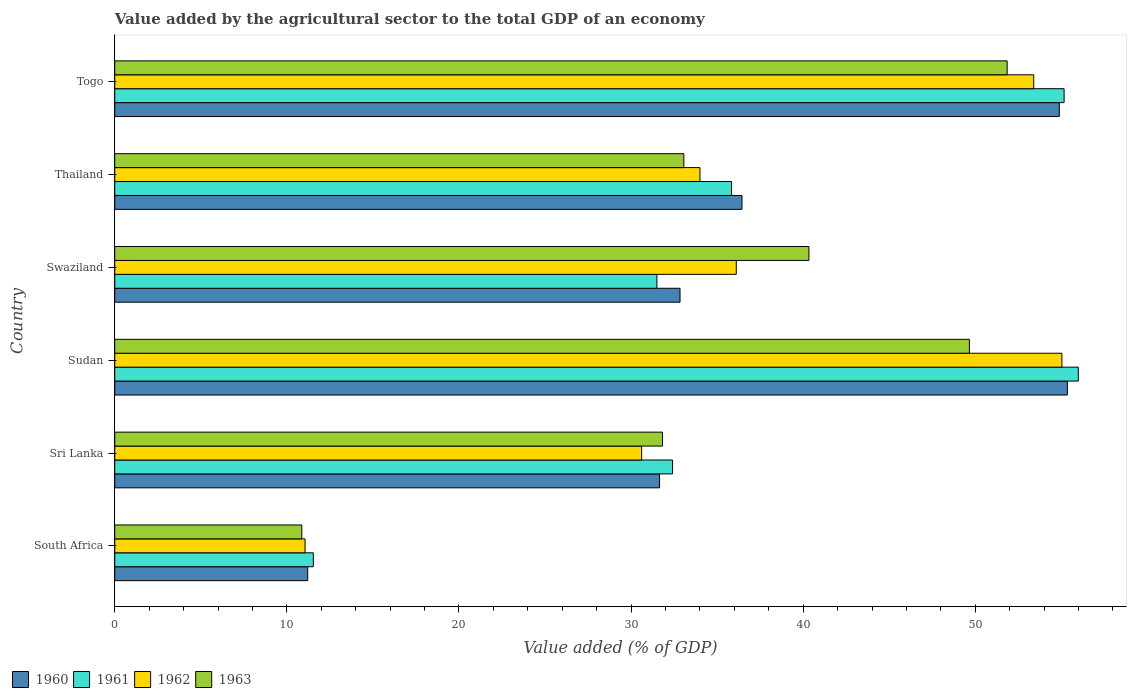How many different coloured bars are there?
Provide a succinct answer. 4. How many groups of bars are there?
Your answer should be compact. 6. What is the label of the 1st group of bars from the top?
Make the answer very short. Togo. In how many cases, is the number of bars for a given country not equal to the number of legend labels?
Offer a terse response. 0. What is the value added by the agricultural sector to the total GDP in 1961 in Togo?
Your answer should be compact. 55.16. Across all countries, what is the maximum value added by the agricultural sector to the total GDP in 1960?
Ensure brevity in your answer.  55.35. Across all countries, what is the minimum value added by the agricultural sector to the total GDP in 1960?
Give a very brief answer. 11.21. In which country was the value added by the agricultural sector to the total GDP in 1961 maximum?
Provide a short and direct response. Sudan. In which country was the value added by the agricultural sector to the total GDP in 1962 minimum?
Make the answer very short. South Africa. What is the total value added by the agricultural sector to the total GDP in 1961 in the graph?
Your response must be concise. 222.43. What is the difference between the value added by the agricultural sector to the total GDP in 1960 in South Africa and that in Sri Lanka?
Offer a very short reply. -20.45. What is the difference between the value added by the agricultural sector to the total GDP in 1963 in Sudan and the value added by the agricultural sector to the total GDP in 1962 in Thailand?
Give a very brief answer. 15.66. What is the average value added by the agricultural sector to the total GDP in 1961 per country?
Your answer should be very brief. 37.07. What is the difference between the value added by the agricultural sector to the total GDP in 1963 and value added by the agricultural sector to the total GDP in 1960 in Swaziland?
Provide a succinct answer. 7.49. What is the ratio of the value added by the agricultural sector to the total GDP in 1960 in Sri Lanka to that in Thailand?
Offer a terse response. 0.87. Is the difference between the value added by the agricultural sector to the total GDP in 1963 in South Africa and Sri Lanka greater than the difference between the value added by the agricultural sector to the total GDP in 1960 in South Africa and Sri Lanka?
Keep it short and to the point. No. What is the difference between the highest and the second highest value added by the agricultural sector to the total GDP in 1960?
Ensure brevity in your answer.  0.47. What is the difference between the highest and the lowest value added by the agricultural sector to the total GDP in 1961?
Give a very brief answer. 44.45. Is the sum of the value added by the agricultural sector to the total GDP in 1961 in South Africa and Sri Lanka greater than the maximum value added by the agricultural sector to the total GDP in 1963 across all countries?
Your answer should be very brief. No. Is it the case that in every country, the sum of the value added by the agricultural sector to the total GDP in 1962 and value added by the agricultural sector to the total GDP in 1960 is greater than the sum of value added by the agricultural sector to the total GDP in 1961 and value added by the agricultural sector to the total GDP in 1963?
Keep it short and to the point. No. What does the 3rd bar from the top in South Africa represents?
Give a very brief answer. 1961. Are all the bars in the graph horizontal?
Your response must be concise. Yes. How many countries are there in the graph?
Make the answer very short. 6. Are the values on the major ticks of X-axis written in scientific E-notation?
Offer a terse response. No. Does the graph contain any zero values?
Your answer should be compact. No. Does the graph contain grids?
Provide a succinct answer. No. Where does the legend appear in the graph?
Offer a very short reply. Bottom left. How are the legend labels stacked?
Your answer should be compact. Horizontal. What is the title of the graph?
Keep it short and to the point. Value added by the agricultural sector to the total GDP of an economy. What is the label or title of the X-axis?
Make the answer very short. Value added (% of GDP). What is the label or title of the Y-axis?
Make the answer very short. Country. What is the Value added (% of GDP) of 1960 in South Africa?
Keep it short and to the point. 11.21. What is the Value added (% of GDP) in 1961 in South Africa?
Make the answer very short. 11.54. What is the Value added (% of GDP) of 1962 in South Africa?
Keep it short and to the point. 11.06. What is the Value added (% of GDP) of 1963 in South Africa?
Your response must be concise. 10.87. What is the Value added (% of GDP) in 1960 in Sri Lanka?
Offer a very short reply. 31.66. What is the Value added (% of GDP) in 1961 in Sri Lanka?
Keep it short and to the point. 32.41. What is the Value added (% of GDP) of 1962 in Sri Lanka?
Offer a terse response. 30.61. What is the Value added (% of GDP) in 1963 in Sri Lanka?
Your answer should be compact. 31.83. What is the Value added (% of GDP) in 1960 in Sudan?
Provide a short and direct response. 55.35. What is the Value added (% of GDP) in 1961 in Sudan?
Give a very brief answer. 55.99. What is the Value added (% of GDP) in 1962 in Sudan?
Ensure brevity in your answer.  55.03. What is the Value added (% of GDP) of 1963 in Sudan?
Your answer should be very brief. 49.66. What is the Value added (% of GDP) in 1960 in Swaziland?
Offer a terse response. 32.84. What is the Value added (% of GDP) in 1961 in Swaziland?
Give a very brief answer. 31.5. What is the Value added (% of GDP) of 1962 in Swaziland?
Provide a succinct answer. 36.11. What is the Value added (% of GDP) of 1963 in Swaziland?
Provide a short and direct response. 40.33. What is the Value added (% of GDP) of 1960 in Thailand?
Ensure brevity in your answer.  36.44. What is the Value added (% of GDP) of 1961 in Thailand?
Ensure brevity in your answer.  35.84. What is the Value added (% of GDP) in 1962 in Thailand?
Provide a succinct answer. 34. What is the Value added (% of GDP) in 1963 in Thailand?
Provide a succinct answer. 33.07. What is the Value added (% of GDP) of 1960 in Togo?
Your answer should be very brief. 54.88. What is the Value added (% of GDP) of 1961 in Togo?
Give a very brief answer. 55.16. What is the Value added (% of GDP) in 1962 in Togo?
Ensure brevity in your answer.  53.4. What is the Value added (% of GDP) of 1963 in Togo?
Your answer should be very brief. 51.85. Across all countries, what is the maximum Value added (% of GDP) in 1960?
Your response must be concise. 55.35. Across all countries, what is the maximum Value added (% of GDP) in 1961?
Your answer should be compact. 55.99. Across all countries, what is the maximum Value added (% of GDP) in 1962?
Your answer should be compact. 55.03. Across all countries, what is the maximum Value added (% of GDP) in 1963?
Give a very brief answer. 51.85. Across all countries, what is the minimum Value added (% of GDP) in 1960?
Make the answer very short. 11.21. Across all countries, what is the minimum Value added (% of GDP) of 1961?
Provide a short and direct response. 11.54. Across all countries, what is the minimum Value added (% of GDP) in 1962?
Provide a succinct answer. 11.06. Across all countries, what is the minimum Value added (% of GDP) of 1963?
Offer a terse response. 10.87. What is the total Value added (% of GDP) of 1960 in the graph?
Your answer should be very brief. 222.39. What is the total Value added (% of GDP) in 1961 in the graph?
Ensure brevity in your answer.  222.44. What is the total Value added (% of GDP) in 1962 in the graph?
Your response must be concise. 220.21. What is the total Value added (% of GDP) in 1963 in the graph?
Provide a succinct answer. 217.6. What is the difference between the Value added (% of GDP) in 1960 in South Africa and that in Sri Lanka?
Provide a succinct answer. -20.45. What is the difference between the Value added (% of GDP) of 1961 in South Africa and that in Sri Lanka?
Your answer should be very brief. -20.87. What is the difference between the Value added (% of GDP) of 1962 in South Africa and that in Sri Lanka?
Offer a very short reply. -19.56. What is the difference between the Value added (% of GDP) of 1963 in South Africa and that in Sri Lanka?
Keep it short and to the point. -20.96. What is the difference between the Value added (% of GDP) in 1960 in South Africa and that in Sudan?
Keep it short and to the point. -44.14. What is the difference between the Value added (% of GDP) of 1961 in South Africa and that in Sudan?
Give a very brief answer. -44.45. What is the difference between the Value added (% of GDP) of 1962 in South Africa and that in Sudan?
Provide a short and direct response. -43.98. What is the difference between the Value added (% of GDP) of 1963 in South Africa and that in Sudan?
Ensure brevity in your answer.  -38.79. What is the difference between the Value added (% of GDP) of 1960 in South Africa and that in Swaziland?
Make the answer very short. -21.63. What is the difference between the Value added (% of GDP) of 1961 in South Africa and that in Swaziland?
Your answer should be compact. -19.96. What is the difference between the Value added (% of GDP) of 1962 in South Africa and that in Swaziland?
Your response must be concise. -25.06. What is the difference between the Value added (% of GDP) in 1963 in South Africa and that in Swaziland?
Give a very brief answer. -29.46. What is the difference between the Value added (% of GDP) in 1960 in South Africa and that in Thailand?
Provide a succinct answer. -25.23. What is the difference between the Value added (% of GDP) of 1961 in South Africa and that in Thailand?
Ensure brevity in your answer.  -24.3. What is the difference between the Value added (% of GDP) in 1962 in South Africa and that in Thailand?
Offer a terse response. -22.95. What is the difference between the Value added (% of GDP) in 1963 in South Africa and that in Thailand?
Your answer should be very brief. -22.2. What is the difference between the Value added (% of GDP) in 1960 in South Africa and that in Togo?
Make the answer very short. -43.67. What is the difference between the Value added (% of GDP) in 1961 in South Africa and that in Togo?
Your answer should be compact. -43.62. What is the difference between the Value added (% of GDP) of 1962 in South Africa and that in Togo?
Keep it short and to the point. -42.34. What is the difference between the Value added (% of GDP) of 1963 in South Africa and that in Togo?
Ensure brevity in your answer.  -40.98. What is the difference between the Value added (% of GDP) of 1960 in Sri Lanka and that in Sudan?
Keep it short and to the point. -23.7. What is the difference between the Value added (% of GDP) in 1961 in Sri Lanka and that in Sudan?
Keep it short and to the point. -23.58. What is the difference between the Value added (% of GDP) in 1962 in Sri Lanka and that in Sudan?
Give a very brief answer. -24.42. What is the difference between the Value added (% of GDP) in 1963 in Sri Lanka and that in Sudan?
Your answer should be very brief. -17.83. What is the difference between the Value added (% of GDP) in 1960 in Sri Lanka and that in Swaziland?
Make the answer very short. -1.19. What is the difference between the Value added (% of GDP) in 1961 in Sri Lanka and that in Swaziland?
Ensure brevity in your answer.  0.91. What is the difference between the Value added (% of GDP) of 1962 in Sri Lanka and that in Swaziland?
Offer a terse response. -5.5. What is the difference between the Value added (% of GDP) in 1963 in Sri Lanka and that in Swaziland?
Provide a succinct answer. -8.51. What is the difference between the Value added (% of GDP) of 1960 in Sri Lanka and that in Thailand?
Provide a short and direct response. -4.79. What is the difference between the Value added (% of GDP) of 1961 in Sri Lanka and that in Thailand?
Your answer should be very brief. -3.43. What is the difference between the Value added (% of GDP) of 1962 in Sri Lanka and that in Thailand?
Ensure brevity in your answer.  -3.39. What is the difference between the Value added (% of GDP) in 1963 in Sri Lanka and that in Thailand?
Give a very brief answer. -1.24. What is the difference between the Value added (% of GDP) of 1960 in Sri Lanka and that in Togo?
Make the answer very short. -23.23. What is the difference between the Value added (% of GDP) in 1961 in Sri Lanka and that in Togo?
Your response must be concise. -22.75. What is the difference between the Value added (% of GDP) of 1962 in Sri Lanka and that in Togo?
Offer a terse response. -22.78. What is the difference between the Value added (% of GDP) in 1963 in Sri Lanka and that in Togo?
Provide a succinct answer. -20.03. What is the difference between the Value added (% of GDP) in 1960 in Sudan and that in Swaziland?
Provide a short and direct response. 22.51. What is the difference between the Value added (% of GDP) in 1961 in Sudan and that in Swaziland?
Your answer should be compact. 24.49. What is the difference between the Value added (% of GDP) of 1962 in Sudan and that in Swaziland?
Offer a terse response. 18.92. What is the difference between the Value added (% of GDP) in 1963 in Sudan and that in Swaziland?
Give a very brief answer. 9.32. What is the difference between the Value added (% of GDP) in 1960 in Sudan and that in Thailand?
Offer a terse response. 18.91. What is the difference between the Value added (% of GDP) of 1961 in Sudan and that in Thailand?
Keep it short and to the point. 20.15. What is the difference between the Value added (% of GDP) in 1962 in Sudan and that in Thailand?
Provide a succinct answer. 21.03. What is the difference between the Value added (% of GDP) in 1963 in Sudan and that in Thailand?
Give a very brief answer. 16.59. What is the difference between the Value added (% of GDP) of 1960 in Sudan and that in Togo?
Your response must be concise. 0.47. What is the difference between the Value added (% of GDP) in 1961 in Sudan and that in Togo?
Provide a short and direct response. 0.83. What is the difference between the Value added (% of GDP) in 1962 in Sudan and that in Togo?
Provide a succinct answer. 1.64. What is the difference between the Value added (% of GDP) of 1963 in Sudan and that in Togo?
Offer a terse response. -2.19. What is the difference between the Value added (% of GDP) of 1960 in Swaziland and that in Thailand?
Provide a succinct answer. -3.6. What is the difference between the Value added (% of GDP) in 1961 in Swaziland and that in Thailand?
Your answer should be very brief. -4.34. What is the difference between the Value added (% of GDP) in 1962 in Swaziland and that in Thailand?
Offer a very short reply. 2.11. What is the difference between the Value added (% of GDP) of 1963 in Swaziland and that in Thailand?
Ensure brevity in your answer.  7.27. What is the difference between the Value added (% of GDP) of 1960 in Swaziland and that in Togo?
Ensure brevity in your answer.  -22.04. What is the difference between the Value added (% of GDP) in 1961 in Swaziland and that in Togo?
Your answer should be very brief. -23.66. What is the difference between the Value added (% of GDP) in 1962 in Swaziland and that in Togo?
Make the answer very short. -17.28. What is the difference between the Value added (% of GDP) of 1963 in Swaziland and that in Togo?
Provide a succinct answer. -11.52. What is the difference between the Value added (% of GDP) of 1960 in Thailand and that in Togo?
Keep it short and to the point. -18.44. What is the difference between the Value added (% of GDP) of 1961 in Thailand and that in Togo?
Give a very brief answer. -19.32. What is the difference between the Value added (% of GDP) of 1962 in Thailand and that in Togo?
Keep it short and to the point. -19.39. What is the difference between the Value added (% of GDP) in 1963 in Thailand and that in Togo?
Give a very brief answer. -18.79. What is the difference between the Value added (% of GDP) of 1960 in South Africa and the Value added (% of GDP) of 1961 in Sri Lanka?
Provide a succinct answer. -21.2. What is the difference between the Value added (% of GDP) in 1960 in South Africa and the Value added (% of GDP) in 1962 in Sri Lanka?
Your answer should be compact. -19.4. What is the difference between the Value added (% of GDP) in 1960 in South Africa and the Value added (% of GDP) in 1963 in Sri Lanka?
Keep it short and to the point. -20.62. What is the difference between the Value added (% of GDP) in 1961 in South Africa and the Value added (% of GDP) in 1962 in Sri Lanka?
Keep it short and to the point. -19.08. What is the difference between the Value added (% of GDP) in 1961 in South Africa and the Value added (% of GDP) in 1963 in Sri Lanka?
Your response must be concise. -20.29. What is the difference between the Value added (% of GDP) in 1962 in South Africa and the Value added (% of GDP) in 1963 in Sri Lanka?
Your answer should be very brief. -20.77. What is the difference between the Value added (% of GDP) of 1960 in South Africa and the Value added (% of GDP) of 1961 in Sudan?
Ensure brevity in your answer.  -44.78. What is the difference between the Value added (% of GDP) of 1960 in South Africa and the Value added (% of GDP) of 1962 in Sudan?
Give a very brief answer. -43.82. What is the difference between the Value added (% of GDP) of 1960 in South Africa and the Value added (% of GDP) of 1963 in Sudan?
Keep it short and to the point. -38.45. What is the difference between the Value added (% of GDP) of 1961 in South Africa and the Value added (% of GDP) of 1962 in Sudan?
Give a very brief answer. -43.5. What is the difference between the Value added (% of GDP) in 1961 in South Africa and the Value added (% of GDP) in 1963 in Sudan?
Ensure brevity in your answer.  -38.12. What is the difference between the Value added (% of GDP) in 1962 in South Africa and the Value added (% of GDP) in 1963 in Sudan?
Offer a terse response. -38.6. What is the difference between the Value added (% of GDP) in 1960 in South Africa and the Value added (% of GDP) in 1961 in Swaziland?
Keep it short and to the point. -20.29. What is the difference between the Value added (% of GDP) of 1960 in South Africa and the Value added (% of GDP) of 1962 in Swaziland?
Your answer should be very brief. -24.9. What is the difference between the Value added (% of GDP) of 1960 in South Africa and the Value added (% of GDP) of 1963 in Swaziland?
Offer a very short reply. -29.12. What is the difference between the Value added (% of GDP) of 1961 in South Africa and the Value added (% of GDP) of 1962 in Swaziland?
Provide a succinct answer. -24.58. What is the difference between the Value added (% of GDP) of 1961 in South Africa and the Value added (% of GDP) of 1963 in Swaziland?
Keep it short and to the point. -28.8. What is the difference between the Value added (% of GDP) of 1962 in South Africa and the Value added (% of GDP) of 1963 in Swaziland?
Offer a very short reply. -29.28. What is the difference between the Value added (% of GDP) in 1960 in South Africa and the Value added (% of GDP) in 1961 in Thailand?
Ensure brevity in your answer.  -24.63. What is the difference between the Value added (% of GDP) of 1960 in South Africa and the Value added (% of GDP) of 1962 in Thailand?
Your answer should be compact. -22.79. What is the difference between the Value added (% of GDP) of 1960 in South Africa and the Value added (% of GDP) of 1963 in Thailand?
Give a very brief answer. -21.86. What is the difference between the Value added (% of GDP) in 1961 in South Africa and the Value added (% of GDP) in 1962 in Thailand?
Keep it short and to the point. -22.47. What is the difference between the Value added (% of GDP) of 1961 in South Africa and the Value added (% of GDP) of 1963 in Thailand?
Provide a succinct answer. -21.53. What is the difference between the Value added (% of GDP) of 1962 in South Africa and the Value added (% of GDP) of 1963 in Thailand?
Your answer should be very brief. -22.01. What is the difference between the Value added (% of GDP) of 1960 in South Africa and the Value added (% of GDP) of 1961 in Togo?
Offer a terse response. -43.95. What is the difference between the Value added (% of GDP) of 1960 in South Africa and the Value added (% of GDP) of 1962 in Togo?
Your answer should be very brief. -42.18. What is the difference between the Value added (% of GDP) in 1960 in South Africa and the Value added (% of GDP) in 1963 in Togo?
Your answer should be very brief. -40.64. What is the difference between the Value added (% of GDP) of 1961 in South Africa and the Value added (% of GDP) of 1962 in Togo?
Your answer should be compact. -41.86. What is the difference between the Value added (% of GDP) of 1961 in South Africa and the Value added (% of GDP) of 1963 in Togo?
Give a very brief answer. -40.31. What is the difference between the Value added (% of GDP) in 1962 in South Africa and the Value added (% of GDP) in 1963 in Togo?
Offer a terse response. -40.8. What is the difference between the Value added (% of GDP) in 1960 in Sri Lanka and the Value added (% of GDP) in 1961 in Sudan?
Your answer should be compact. -24.33. What is the difference between the Value added (% of GDP) of 1960 in Sri Lanka and the Value added (% of GDP) of 1962 in Sudan?
Your response must be concise. -23.38. What is the difference between the Value added (% of GDP) in 1960 in Sri Lanka and the Value added (% of GDP) in 1963 in Sudan?
Your response must be concise. -18. What is the difference between the Value added (% of GDP) in 1961 in Sri Lanka and the Value added (% of GDP) in 1962 in Sudan?
Keep it short and to the point. -22.62. What is the difference between the Value added (% of GDP) of 1961 in Sri Lanka and the Value added (% of GDP) of 1963 in Sudan?
Offer a very short reply. -17.25. What is the difference between the Value added (% of GDP) in 1962 in Sri Lanka and the Value added (% of GDP) in 1963 in Sudan?
Provide a succinct answer. -19.04. What is the difference between the Value added (% of GDP) in 1960 in Sri Lanka and the Value added (% of GDP) in 1961 in Swaziland?
Your answer should be compact. 0.16. What is the difference between the Value added (% of GDP) in 1960 in Sri Lanka and the Value added (% of GDP) in 1962 in Swaziland?
Offer a terse response. -4.46. What is the difference between the Value added (% of GDP) in 1960 in Sri Lanka and the Value added (% of GDP) in 1963 in Swaziland?
Your response must be concise. -8.68. What is the difference between the Value added (% of GDP) in 1961 in Sri Lanka and the Value added (% of GDP) in 1962 in Swaziland?
Your answer should be compact. -3.7. What is the difference between the Value added (% of GDP) in 1961 in Sri Lanka and the Value added (% of GDP) in 1963 in Swaziland?
Your answer should be compact. -7.92. What is the difference between the Value added (% of GDP) in 1962 in Sri Lanka and the Value added (% of GDP) in 1963 in Swaziland?
Make the answer very short. -9.72. What is the difference between the Value added (% of GDP) of 1960 in Sri Lanka and the Value added (% of GDP) of 1961 in Thailand?
Offer a terse response. -4.18. What is the difference between the Value added (% of GDP) in 1960 in Sri Lanka and the Value added (% of GDP) in 1962 in Thailand?
Give a very brief answer. -2.35. What is the difference between the Value added (% of GDP) of 1960 in Sri Lanka and the Value added (% of GDP) of 1963 in Thailand?
Provide a succinct answer. -1.41. What is the difference between the Value added (% of GDP) of 1961 in Sri Lanka and the Value added (% of GDP) of 1962 in Thailand?
Your answer should be compact. -1.59. What is the difference between the Value added (% of GDP) of 1961 in Sri Lanka and the Value added (% of GDP) of 1963 in Thailand?
Offer a very short reply. -0.65. What is the difference between the Value added (% of GDP) of 1962 in Sri Lanka and the Value added (% of GDP) of 1963 in Thailand?
Give a very brief answer. -2.45. What is the difference between the Value added (% of GDP) of 1960 in Sri Lanka and the Value added (% of GDP) of 1961 in Togo?
Keep it short and to the point. -23.51. What is the difference between the Value added (% of GDP) in 1960 in Sri Lanka and the Value added (% of GDP) in 1962 in Togo?
Offer a very short reply. -21.74. What is the difference between the Value added (% of GDP) of 1960 in Sri Lanka and the Value added (% of GDP) of 1963 in Togo?
Provide a short and direct response. -20.2. What is the difference between the Value added (% of GDP) of 1961 in Sri Lanka and the Value added (% of GDP) of 1962 in Togo?
Offer a very short reply. -20.98. What is the difference between the Value added (% of GDP) of 1961 in Sri Lanka and the Value added (% of GDP) of 1963 in Togo?
Ensure brevity in your answer.  -19.44. What is the difference between the Value added (% of GDP) in 1962 in Sri Lanka and the Value added (% of GDP) in 1963 in Togo?
Your answer should be very brief. -21.24. What is the difference between the Value added (% of GDP) in 1960 in Sudan and the Value added (% of GDP) in 1961 in Swaziland?
Offer a very short reply. 23.85. What is the difference between the Value added (% of GDP) in 1960 in Sudan and the Value added (% of GDP) in 1962 in Swaziland?
Give a very brief answer. 19.24. What is the difference between the Value added (% of GDP) of 1960 in Sudan and the Value added (% of GDP) of 1963 in Swaziland?
Offer a very short reply. 15.02. What is the difference between the Value added (% of GDP) of 1961 in Sudan and the Value added (% of GDP) of 1962 in Swaziland?
Give a very brief answer. 19.87. What is the difference between the Value added (% of GDP) in 1961 in Sudan and the Value added (% of GDP) in 1963 in Swaziland?
Make the answer very short. 15.65. What is the difference between the Value added (% of GDP) of 1962 in Sudan and the Value added (% of GDP) of 1963 in Swaziland?
Your answer should be compact. 14.7. What is the difference between the Value added (% of GDP) in 1960 in Sudan and the Value added (% of GDP) in 1961 in Thailand?
Your answer should be compact. 19.51. What is the difference between the Value added (% of GDP) of 1960 in Sudan and the Value added (% of GDP) of 1962 in Thailand?
Your response must be concise. 21.35. What is the difference between the Value added (% of GDP) in 1960 in Sudan and the Value added (% of GDP) in 1963 in Thailand?
Give a very brief answer. 22.29. What is the difference between the Value added (% of GDP) of 1961 in Sudan and the Value added (% of GDP) of 1962 in Thailand?
Your answer should be compact. 21.98. What is the difference between the Value added (% of GDP) of 1961 in Sudan and the Value added (% of GDP) of 1963 in Thailand?
Offer a very short reply. 22.92. What is the difference between the Value added (% of GDP) of 1962 in Sudan and the Value added (% of GDP) of 1963 in Thailand?
Provide a short and direct response. 21.97. What is the difference between the Value added (% of GDP) in 1960 in Sudan and the Value added (% of GDP) in 1961 in Togo?
Your answer should be compact. 0.19. What is the difference between the Value added (% of GDP) in 1960 in Sudan and the Value added (% of GDP) in 1962 in Togo?
Make the answer very short. 1.96. What is the difference between the Value added (% of GDP) in 1960 in Sudan and the Value added (% of GDP) in 1963 in Togo?
Offer a terse response. 3.5. What is the difference between the Value added (% of GDP) of 1961 in Sudan and the Value added (% of GDP) of 1962 in Togo?
Provide a succinct answer. 2.59. What is the difference between the Value added (% of GDP) of 1961 in Sudan and the Value added (% of GDP) of 1963 in Togo?
Provide a succinct answer. 4.13. What is the difference between the Value added (% of GDP) in 1962 in Sudan and the Value added (% of GDP) in 1963 in Togo?
Your response must be concise. 3.18. What is the difference between the Value added (% of GDP) in 1960 in Swaziland and the Value added (% of GDP) in 1961 in Thailand?
Provide a succinct answer. -2.99. What is the difference between the Value added (% of GDP) in 1960 in Swaziland and the Value added (% of GDP) in 1962 in Thailand?
Provide a succinct answer. -1.16. What is the difference between the Value added (% of GDP) in 1960 in Swaziland and the Value added (% of GDP) in 1963 in Thailand?
Your response must be concise. -0.22. What is the difference between the Value added (% of GDP) in 1961 in Swaziland and the Value added (% of GDP) in 1962 in Thailand?
Ensure brevity in your answer.  -2.5. What is the difference between the Value added (% of GDP) in 1961 in Swaziland and the Value added (% of GDP) in 1963 in Thailand?
Your answer should be compact. -1.57. What is the difference between the Value added (% of GDP) in 1962 in Swaziland and the Value added (% of GDP) in 1963 in Thailand?
Make the answer very short. 3.05. What is the difference between the Value added (% of GDP) of 1960 in Swaziland and the Value added (% of GDP) of 1961 in Togo?
Keep it short and to the point. -22.32. What is the difference between the Value added (% of GDP) of 1960 in Swaziland and the Value added (% of GDP) of 1962 in Togo?
Make the answer very short. -20.55. What is the difference between the Value added (% of GDP) in 1960 in Swaziland and the Value added (% of GDP) in 1963 in Togo?
Ensure brevity in your answer.  -19.01. What is the difference between the Value added (% of GDP) of 1961 in Swaziland and the Value added (% of GDP) of 1962 in Togo?
Provide a succinct answer. -21.9. What is the difference between the Value added (% of GDP) of 1961 in Swaziland and the Value added (% of GDP) of 1963 in Togo?
Offer a terse response. -20.35. What is the difference between the Value added (% of GDP) of 1962 in Swaziland and the Value added (% of GDP) of 1963 in Togo?
Make the answer very short. -15.74. What is the difference between the Value added (% of GDP) in 1960 in Thailand and the Value added (% of GDP) in 1961 in Togo?
Make the answer very short. -18.72. What is the difference between the Value added (% of GDP) of 1960 in Thailand and the Value added (% of GDP) of 1962 in Togo?
Make the answer very short. -16.95. What is the difference between the Value added (% of GDP) of 1960 in Thailand and the Value added (% of GDP) of 1963 in Togo?
Provide a short and direct response. -15.41. What is the difference between the Value added (% of GDP) of 1961 in Thailand and the Value added (% of GDP) of 1962 in Togo?
Give a very brief answer. -17.56. What is the difference between the Value added (% of GDP) in 1961 in Thailand and the Value added (% of GDP) in 1963 in Togo?
Keep it short and to the point. -16.01. What is the difference between the Value added (% of GDP) in 1962 in Thailand and the Value added (% of GDP) in 1963 in Togo?
Your response must be concise. -17.85. What is the average Value added (% of GDP) in 1960 per country?
Give a very brief answer. 37.06. What is the average Value added (% of GDP) of 1961 per country?
Your response must be concise. 37.07. What is the average Value added (% of GDP) of 1962 per country?
Ensure brevity in your answer.  36.7. What is the average Value added (% of GDP) of 1963 per country?
Provide a short and direct response. 36.27. What is the difference between the Value added (% of GDP) in 1960 and Value added (% of GDP) in 1961 in South Africa?
Your answer should be compact. -0.33. What is the difference between the Value added (% of GDP) of 1960 and Value added (% of GDP) of 1962 in South Africa?
Make the answer very short. 0.15. What is the difference between the Value added (% of GDP) of 1960 and Value added (% of GDP) of 1963 in South Africa?
Give a very brief answer. 0.34. What is the difference between the Value added (% of GDP) in 1961 and Value added (% of GDP) in 1962 in South Africa?
Your response must be concise. 0.48. What is the difference between the Value added (% of GDP) in 1961 and Value added (% of GDP) in 1963 in South Africa?
Give a very brief answer. 0.67. What is the difference between the Value added (% of GDP) in 1962 and Value added (% of GDP) in 1963 in South Africa?
Offer a terse response. 0.19. What is the difference between the Value added (% of GDP) of 1960 and Value added (% of GDP) of 1961 in Sri Lanka?
Offer a very short reply. -0.76. What is the difference between the Value added (% of GDP) in 1960 and Value added (% of GDP) in 1962 in Sri Lanka?
Your answer should be compact. 1.04. What is the difference between the Value added (% of GDP) of 1960 and Value added (% of GDP) of 1963 in Sri Lanka?
Offer a terse response. -0.17. What is the difference between the Value added (% of GDP) of 1961 and Value added (% of GDP) of 1962 in Sri Lanka?
Offer a terse response. 1.8. What is the difference between the Value added (% of GDP) of 1961 and Value added (% of GDP) of 1963 in Sri Lanka?
Offer a terse response. 0.59. What is the difference between the Value added (% of GDP) in 1962 and Value added (% of GDP) in 1963 in Sri Lanka?
Offer a terse response. -1.21. What is the difference between the Value added (% of GDP) in 1960 and Value added (% of GDP) in 1961 in Sudan?
Your answer should be very brief. -0.64. What is the difference between the Value added (% of GDP) of 1960 and Value added (% of GDP) of 1962 in Sudan?
Provide a succinct answer. 0.32. What is the difference between the Value added (% of GDP) of 1960 and Value added (% of GDP) of 1963 in Sudan?
Offer a terse response. 5.69. What is the difference between the Value added (% of GDP) in 1961 and Value added (% of GDP) in 1962 in Sudan?
Your answer should be compact. 0.95. What is the difference between the Value added (% of GDP) in 1961 and Value added (% of GDP) in 1963 in Sudan?
Your answer should be compact. 6.33. What is the difference between the Value added (% of GDP) in 1962 and Value added (% of GDP) in 1963 in Sudan?
Offer a very short reply. 5.37. What is the difference between the Value added (% of GDP) in 1960 and Value added (% of GDP) in 1961 in Swaziland?
Give a very brief answer. 1.35. What is the difference between the Value added (% of GDP) in 1960 and Value added (% of GDP) in 1962 in Swaziland?
Provide a short and direct response. -3.27. What is the difference between the Value added (% of GDP) of 1960 and Value added (% of GDP) of 1963 in Swaziland?
Make the answer very short. -7.49. What is the difference between the Value added (% of GDP) in 1961 and Value added (% of GDP) in 1962 in Swaziland?
Your answer should be very brief. -4.61. What is the difference between the Value added (% of GDP) in 1961 and Value added (% of GDP) in 1963 in Swaziland?
Provide a short and direct response. -8.83. What is the difference between the Value added (% of GDP) in 1962 and Value added (% of GDP) in 1963 in Swaziland?
Offer a very short reply. -4.22. What is the difference between the Value added (% of GDP) in 1960 and Value added (% of GDP) in 1961 in Thailand?
Your response must be concise. 0.61. What is the difference between the Value added (% of GDP) of 1960 and Value added (% of GDP) of 1962 in Thailand?
Make the answer very short. 2.44. What is the difference between the Value added (% of GDP) in 1960 and Value added (% of GDP) in 1963 in Thailand?
Keep it short and to the point. 3.38. What is the difference between the Value added (% of GDP) in 1961 and Value added (% of GDP) in 1962 in Thailand?
Make the answer very short. 1.84. What is the difference between the Value added (% of GDP) in 1961 and Value added (% of GDP) in 1963 in Thailand?
Offer a terse response. 2.77. What is the difference between the Value added (% of GDP) of 1962 and Value added (% of GDP) of 1963 in Thailand?
Your response must be concise. 0.94. What is the difference between the Value added (% of GDP) of 1960 and Value added (% of GDP) of 1961 in Togo?
Your response must be concise. -0.28. What is the difference between the Value added (% of GDP) in 1960 and Value added (% of GDP) in 1962 in Togo?
Offer a terse response. 1.49. What is the difference between the Value added (% of GDP) of 1960 and Value added (% of GDP) of 1963 in Togo?
Provide a succinct answer. 3.03. What is the difference between the Value added (% of GDP) in 1961 and Value added (% of GDP) in 1962 in Togo?
Your answer should be compact. 1.77. What is the difference between the Value added (% of GDP) in 1961 and Value added (% of GDP) in 1963 in Togo?
Give a very brief answer. 3.31. What is the difference between the Value added (% of GDP) of 1962 and Value added (% of GDP) of 1963 in Togo?
Give a very brief answer. 1.54. What is the ratio of the Value added (% of GDP) of 1960 in South Africa to that in Sri Lanka?
Your answer should be compact. 0.35. What is the ratio of the Value added (% of GDP) of 1961 in South Africa to that in Sri Lanka?
Your answer should be compact. 0.36. What is the ratio of the Value added (% of GDP) of 1962 in South Africa to that in Sri Lanka?
Provide a succinct answer. 0.36. What is the ratio of the Value added (% of GDP) of 1963 in South Africa to that in Sri Lanka?
Provide a short and direct response. 0.34. What is the ratio of the Value added (% of GDP) of 1960 in South Africa to that in Sudan?
Keep it short and to the point. 0.2. What is the ratio of the Value added (% of GDP) in 1961 in South Africa to that in Sudan?
Your answer should be very brief. 0.21. What is the ratio of the Value added (% of GDP) of 1962 in South Africa to that in Sudan?
Offer a terse response. 0.2. What is the ratio of the Value added (% of GDP) of 1963 in South Africa to that in Sudan?
Give a very brief answer. 0.22. What is the ratio of the Value added (% of GDP) in 1960 in South Africa to that in Swaziland?
Offer a very short reply. 0.34. What is the ratio of the Value added (% of GDP) in 1961 in South Africa to that in Swaziland?
Provide a succinct answer. 0.37. What is the ratio of the Value added (% of GDP) in 1962 in South Africa to that in Swaziland?
Keep it short and to the point. 0.31. What is the ratio of the Value added (% of GDP) in 1963 in South Africa to that in Swaziland?
Your response must be concise. 0.27. What is the ratio of the Value added (% of GDP) of 1960 in South Africa to that in Thailand?
Make the answer very short. 0.31. What is the ratio of the Value added (% of GDP) in 1961 in South Africa to that in Thailand?
Provide a succinct answer. 0.32. What is the ratio of the Value added (% of GDP) of 1962 in South Africa to that in Thailand?
Keep it short and to the point. 0.33. What is the ratio of the Value added (% of GDP) in 1963 in South Africa to that in Thailand?
Provide a succinct answer. 0.33. What is the ratio of the Value added (% of GDP) in 1960 in South Africa to that in Togo?
Provide a succinct answer. 0.2. What is the ratio of the Value added (% of GDP) of 1961 in South Africa to that in Togo?
Your answer should be very brief. 0.21. What is the ratio of the Value added (% of GDP) in 1962 in South Africa to that in Togo?
Provide a succinct answer. 0.21. What is the ratio of the Value added (% of GDP) in 1963 in South Africa to that in Togo?
Offer a terse response. 0.21. What is the ratio of the Value added (% of GDP) of 1960 in Sri Lanka to that in Sudan?
Ensure brevity in your answer.  0.57. What is the ratio of the Value added (% of GDP) of 1961 in Sri Lanka to that in Sudan?
Offer a very short reply. 0.58. What is the ratio of the Value added (% of GDP) in 1962 in Sri Lanka to that in Sudan?
Ensure brevity in your answer.  0.56. What is the ratio of the Value added (% of GDP) of 1963 in Sri Lanka to that in Sudan?
Provide a short and direct response. 0.64. What is the ratio of the Value added (% of GDP) in 1960 in Sri Lanka to that in Swaziland?
Offer a terse response. 0.96. What is the ratio of the Value added (% of GDP) in 1961 in Sri Lanka to that in Swaziland?
Ensure brevity in your answer.  1.03. What is the ratio of the Value added (% of GDP) of 1962 in Sri Lanka to that in Swaziland?
Offer a very short reply. 0.85. What is the ratio of the Value added (% of GDP) in 1963 in Sri Lanka to that in Swaziland?
Ensure brevity in your answer.  0.79. What is the ratio of the Value added (% of GDP) in 1960 in Sri Lanka to that in Thailand?
Ensure brevity in your answer.  0.87. What is the ratio of the Value added (% of GDP) in 1961 in Sri Lanka to that in Thailand?
Ensure brevity in your answer.  0.9. What is the ratio of the Value added (% of GDP) in 1962 in Sri Lanka to that in Thailand?
Offer a terse response. 0.9. What is the ratio of the Value added (% of GDP) in 1963 in Sri Lanka to that in Thailand?
Provide a succinct answer. 0.96. What is the ratio of the Value added (% of GDP) of 1960 in Sri Lanka to that in Togo?
Make the answer very short. 0.58. What is the ratio of the Value added (% of GDP) in 1961 in Sri Lanka to that in Togo?
Provide a succinct answer. 0.59. What is the ratio of the Value added (% of GDP) of 1962 in Sri Lanka to that in Togo?
Give a very brief answer. 0.57. What is the ratio of the Value added (% of GDP) in 1963 in Sri Lanka to that in Togo?
Provide a succinct answer. 0.61. What is the ratio of the Value added (% of GDP) in 1960 in Sudan to that in Swaziland?
Your answer should be compact. 1.69. What is the ratio of the Value added (% of GDP) in 1961 in Sudan to that in Swaziland?
Your response must be concise. 1.78. What is the ratio of the Value added (% of GDP) of 1962 in Sudan to that in Swaziland?
Provide a short and direct response. 1.52. What is the ratio of the Value added (% of GDP) in 1963 in Sudan to that in Swaziland?
Your answer should be compact. 1.23. What is the ratio of the Value added (% of GDP) of 1960 in Sudan to that in Thailand?
Provide a succinct answer. 1.52. What is the ratio of the Value added (% of GDP) in 1961 in Sudan to that in Thailand?
Your answer should be compact. 1.56. What is the ratio of the Value added (% of GDP) of 1962 in Sudan to that in Thailand?
Offer a terse response. 1.62. What is the ratio of the Value added (% of GDP) in 1963 in Sudan to that in Thailand?
Your response must be concise. 1.5. What is the ratio of the Value added (% of GDP) of 1960 in Sudan to that in Togo?
Your answer should be compact. 1.01. What is the ratio of the Value added (% of GDP) in 1961 in Sudan to that in Togo?
Provide a short and direct response. 1.01. What is the ratio of the Value added (% of GDP) of 1962 in Sudan to that in Togo?
Offer a very short reply. 1.03. What is the ratio of the Value added (% of GDP) of 1963 in Sudan to that in Togo?
Make the answer very short. 0.96. What is the ratio of the Value added (% of GDP) in 1960 in Swaziland to that in Thailand?
Your answer should be very brief. 0.9. What is the ratio of the Value added (% of GDP) of 1961 in Swaziland to that in Thailand?
Offer a terse response. 0.88. What is the ratio of the Value added (% of GDP) in 1962 in Swaziland to that in Thailand?
Give a very brief answer. 1.06. What is the ratio of the Value added (% of GDP) of 1963 in Swaziland to that in Thailand?
Your response must be concise. 1.22. What is the ratio of the Value added (% of GDP) of 1960 in Swaziland to that in Togo?
Your response must be concise. 0.6. What is the ratio of the Value added (% of GDP) in 1961 in Swaziland to that in Togo?
Make the answer very short. 0.57. What is the ratio of the Value added (% of GDP) of 1962 in Swaziland to that in Togo?
Your answer should be compact. 0.68. What is the ratio of the Value added (% of GDP) in 1963 in Swaziland to that in Togo?
Your answer should be very brief. 0.78. What is the ratio of the Value added (% of GDP) in 1960 in Thailand to that in Togo?
Your answer should be compact. 0.66. What is the ratio of the Value added (% of GDP) in 1961 in Thailand to that in Togo?
Offer a very short reply. 0.65. What is the ratio of the Value added (% of GDP) in 1962 in Thailand to that in Togo?
Give a very brief answer. 0.64. What is the ratio of the Value added (% of GDP) of 1963 in Thailand to that in Togo?
Provide a short and direct response. 0.64. What is the difference between the highest and the second highest Value added (% of GDP) of 1960?
Offer a terse response. 0.47. What is the difference between the highest and the second highest Value added (% of GDP) in 1961?
Ensure brevity in your answer.  0.83. What is the difference between the highest and the second highest Value added (% of GDP) of 1962?
Provide a succinct answer. 1.64. What is the difference between the highest and the second highest Value added (% of GDP) in 1963?
Offer a terse response. 2.19. What is the difference between the highest and the lowest Value added (% of GDP) of 1960?
Provide a short and direct response. 44.14. What is the difference between the highest and the lowest Value added (% of GDP) in 1961?
Provide a succinct answer. 44.45. What is the difference between the highest and the lowest Value added (% of GDP) in 1962?
Provide a succinct answer. 43.98. What is the difference between the highest and the lowest Value added (% of GDP) of 1963?
Give a very brief answer. 40.98. 